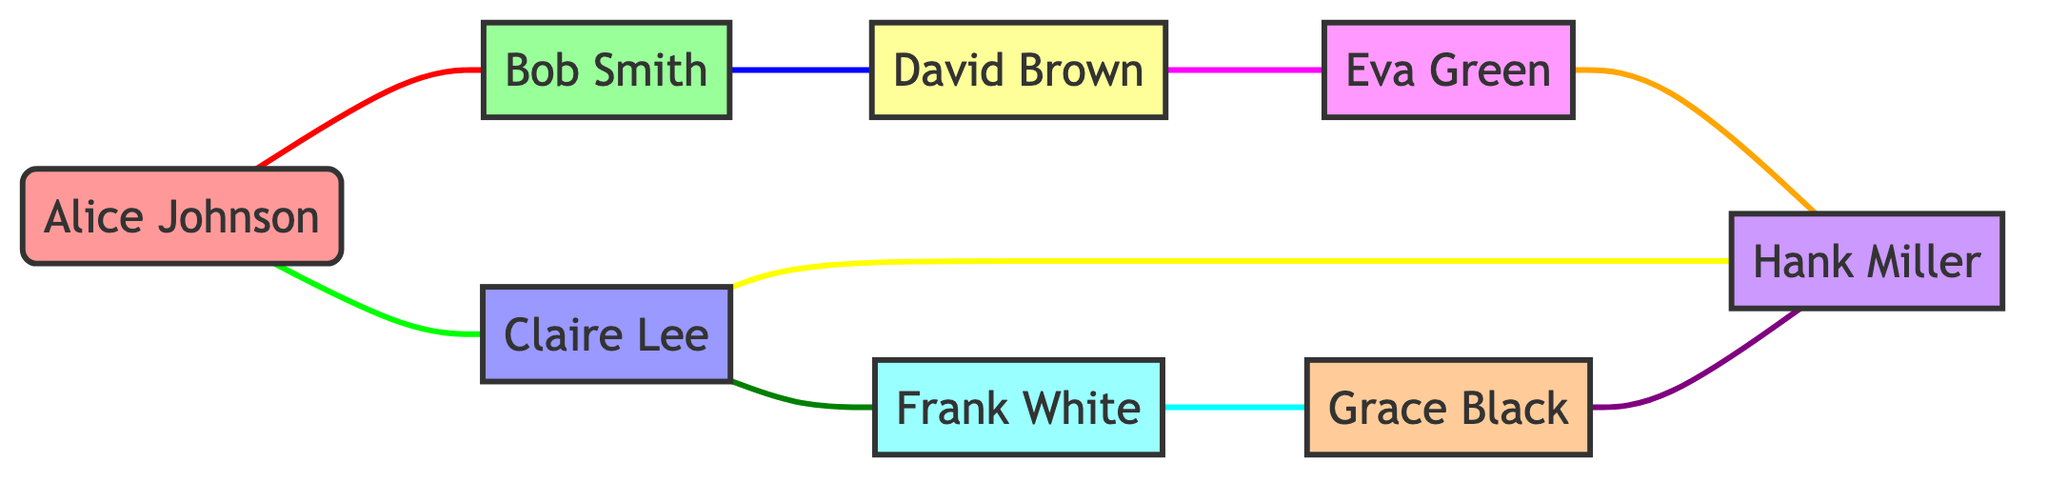What is the total number of employees represented in the graph? To find the total number of employees, we need to count the nodes listed in the data. There are 8 distinct employee nodes: Alice Johnson, Bob Smith, Claire Lee, David Brown, Eva Green, Frank White, Grace Black, and Hank Miller.
Answer: 8 Which employee has the most interactions? To determine which employee has the most interactions, we need to analyze the edges connected to each node. Counting the connections: Alice Johnson has 2, Bob Smith has 2, Claire Lee has 3, David Brown has 2, Eva Green has 2, Frank White has 2, Grace Black has 2, and Hank Miller has 3. Both Claire Lee and Hank Miller have the highest count of 3.
Answer: Claire Lee, Hank Miller What type of interaction exists between Alice Johnson and Bob Smith? We find the edge between Alice Johnson and Bob Smith in the data. The interaction listed for this connection is a weekly sales meeting.
Answer: weekly sales meeting How many interactions involve Frank White? To find the interactions involving Frank White, we count how many edges connect to his node. He is connected to Grace Black and Claire Lee, thus having 2 interactions in total.
Answer: 2 What departments are represented in the interactions between David Brown and Eva Green? David Brown belongs to the Customer Support department, and Eva Green is part of the HR department. Therefore, the departments in the interaction are Customer Support and HR.
Answer: Customer Support, HR How many unique departments are represented among the employees? By listing the departments for each employee, we identify Marketing, Sales, Engineering, Customer Support, HR, Finance, Operations, and Product Management. There are 8 unique departments based on these classifications.
Answer: 8 Who collaborates on the feature implementation project? The edge data indicates that Claire Lee and Hank Miller are collaborating for the feature implementation project, as they are directly connected through this edge.
Answer: Claire Lee, Hank Miller In how many interactions is Hank Miller involved? We review the edges connected to Hank Miller: He interacts with Claire Lee, Eva Green, and Grace Black which totals to 3 interactions.
Answer: 3 